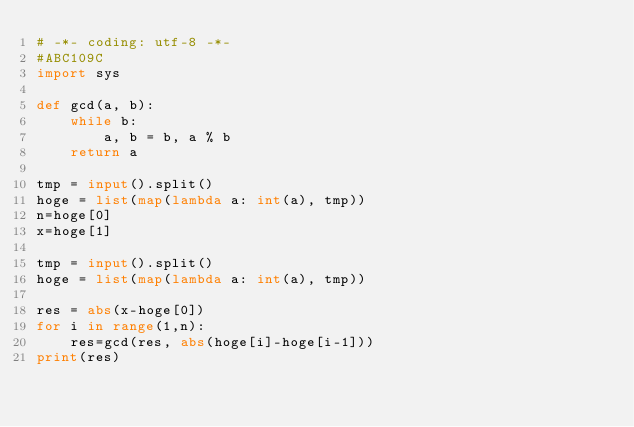<code> <loc_0><loc_0><loc_500><loc_500><_Python_># -*- coding: utf-8 -*-
#ABC109C
import sys

def gcd(a, b):
	while b:
		a, b = b, a % b
	return a

tmp = input().split()
hoge = list(map(lambda a: int(a), tmp))
n=hoge[0]
x=hoge[1]

tmp = input().split()
hoge = list(map(lambda a: int(a), tmp))

res = abs(x-hoge[0])
for i in range(1,n):
	res=gcd(res, abs(hoge[i]-hoge[i-1]))
print(res)</code> 